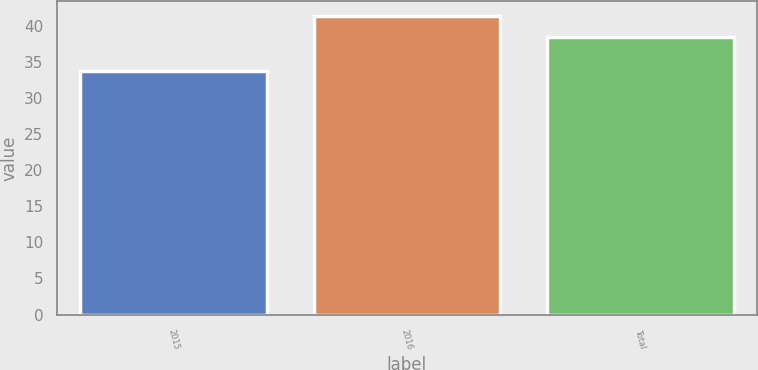<chart> <loc_0><loc_0><loc_500><loc_500><bar_chart><fcel>2015<fcel>2016<fcel>Total<nl><fcel>33.76<fcel>41.4<fcel>38.5<nl></chart> 